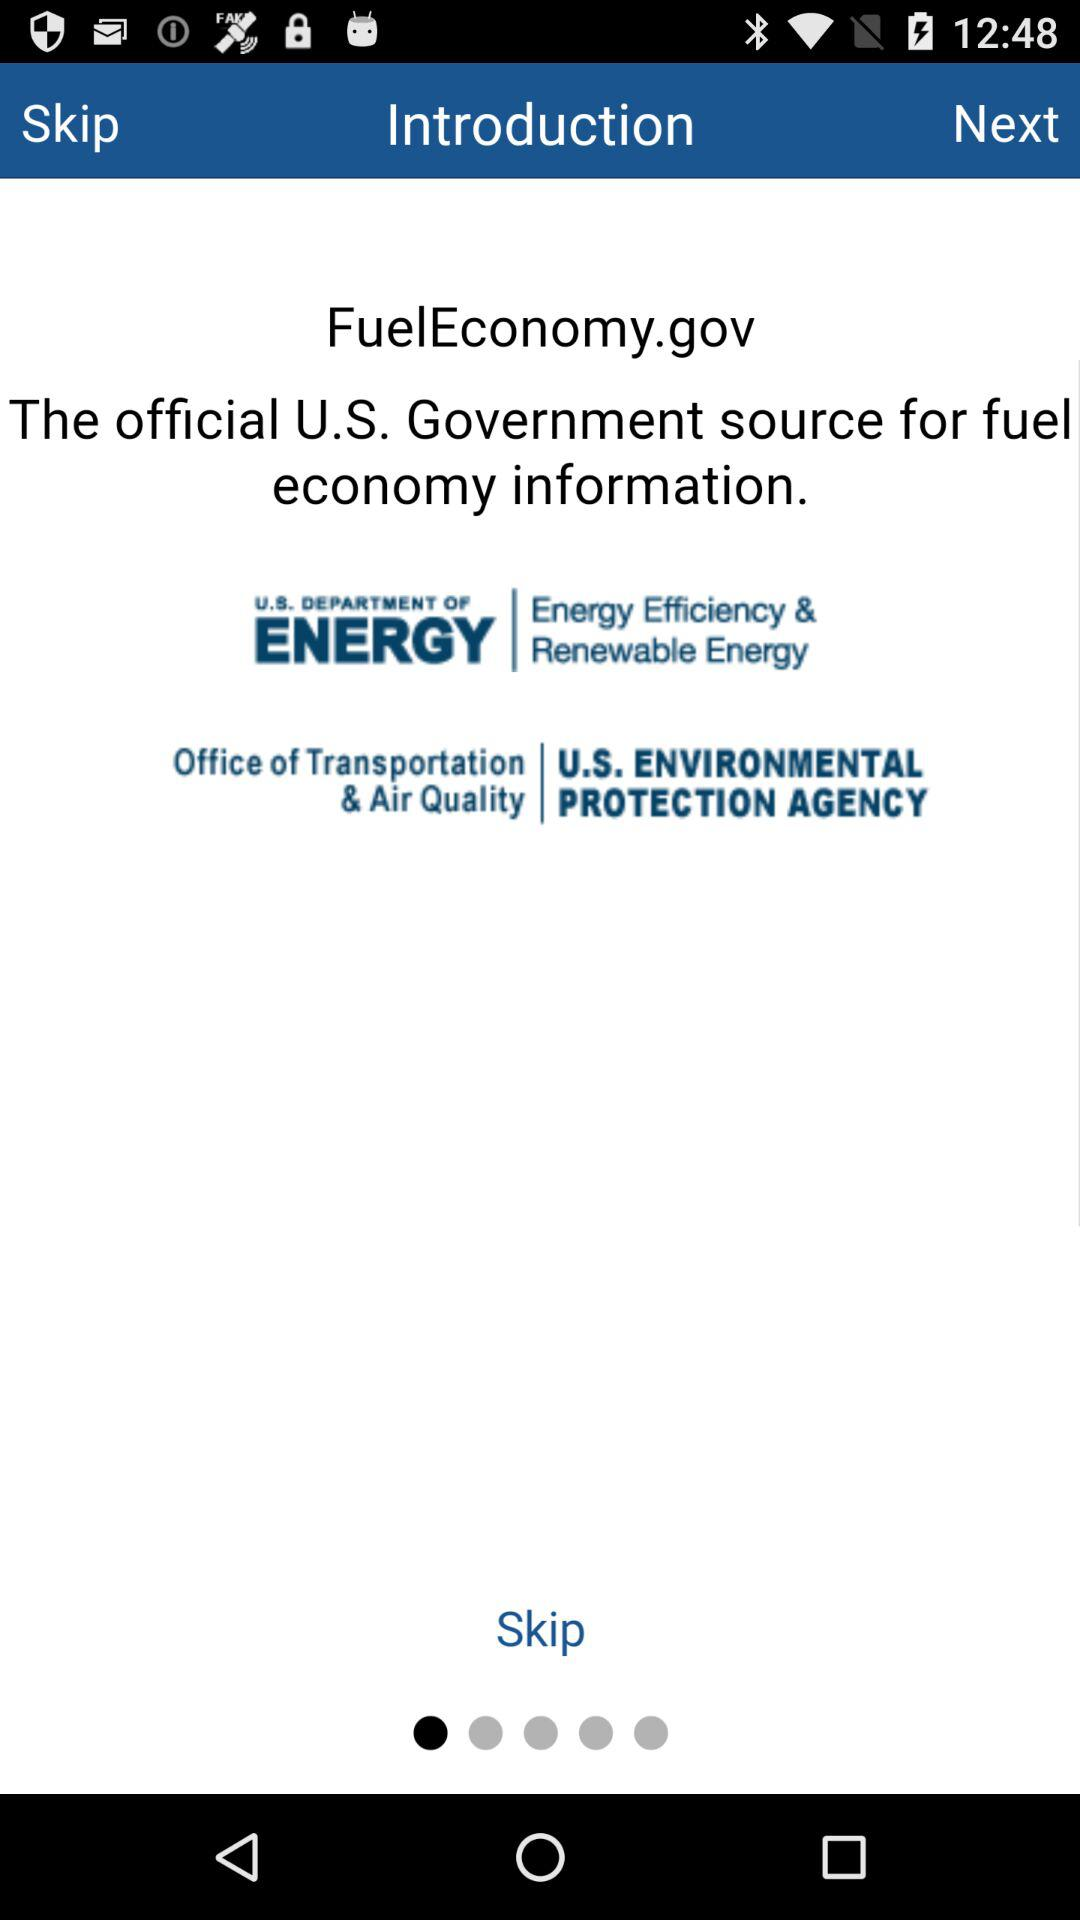What is the official source of the U.S. government's fuel economy information? The official source is FuelEconomy.gov. 